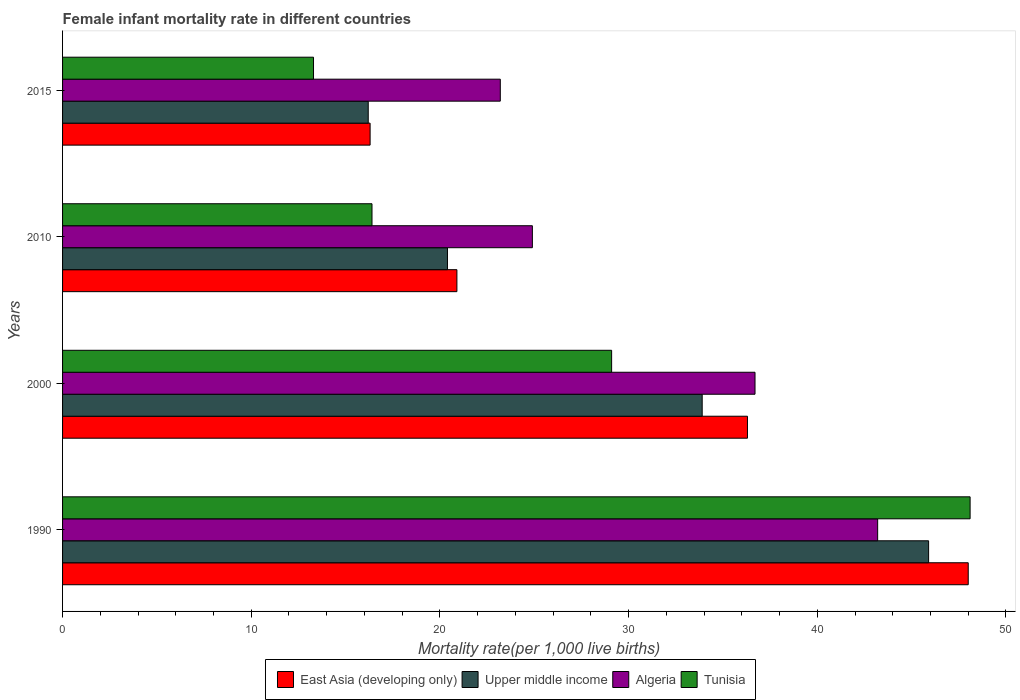Are the number of bars per tick equal to the number of legend labels?
Provide a succinct answer. Yes. Are the number of bars on each tick of the Y-axis equal?
Provide a succinct answer. Yes. How many bars are there on the 2nd tick from the bottom?
Provide a short and direct response. 4. What is the label of the 2nd group of bars from the top?
Your response must be concise. 2010. What is the female infant mortality rate in Algeria in 1990?
Offer a terse response. 43.2. Across all years, what is the maximum female infant mortality rate in East Asia (developing only)?
Your answer should be compact. 48. Across all years, what is the minimum female infant mortality rate in Upper middle income?
Give a very brief answer. 16.2. In which year was the female infant mortality rate in Algeria maximum?
Give a very brief answer. 1990. In which year was the female infant mortality rate in East Asia (developing only) minimum?
Ensure brevity in your answer.  2015. What is the total female infant mortality rate in Algeria in the graph?
Your answer should be very brief. 128. What is the difference between the female infant mortality rate in Tunisia in 1990 and that in 2010?
Keep it short and to the point. 31.7. What is the difference between the female infant mortality rate in East Asia (developing only) in 1990 and the female infant mortality rate in Algeria in 2010?
Provide a short and direct response. 23.1. In the year 2010, what is the difference between the female infant mortality rate in East Asia (developing only) and female infant mortality rate in Tunisia?
Keep it short and to the point. 4.5. What is the ratio of the female infant mortality rate in Upper middle income in 2010 to that in 2015?
Give a very brief answer. 1.26. Is the female infant mortality rate in Algeria in 2010 less than that in 2015?
Ensure brevity in your answer.  No. Is the difference between the female infant mortality rate in East Asia (developing only) in 1990 and 2000 greater than the difference between the female infant mortality rate in Tunisia in 1990 and 2000?
Your response must be concise. No. What is the difference between the highest and the second highest female infant mortality rate in East Asia (developing only)?
Your answer should be very brief. 11.7. What is the difference between the highest and the lowest female infant mortality rate in East Asia (developing only)?
Offer a very short reply. 31.7. In how many years, is the female infant mortality rate in Tunisia greater than the average female infant mortality rate in Tunisia taken over all years?
Provide a short and direct response. 2. Is it the case that in every year, the sum of the female infant mortality rate in Upper middle income and female infant mortality rate in Algeria is greater than the sum of female infant mortality rate in Tunisia and female infant mortality rate in East Asia (developing only)?
Your answer should be compact. No. What does the 3rd bar from the top in 1990 represents?
Provide a succinct answer. Upper middle income. What does the 4th bar from the bottom in 2000 represents?
Your answer should be very brief. Tunisia. Are all the bars in the graph horizontal?
Offer a terse response. Yes. How many years are there in the graph?
Your response must be concise. 4. Are the values on the major ticks of X-axis written in scientific E-notation?
Your response must be concise. No. Does the graph contain any zero values?
Provide a short and direct response. No. Does the graph contain grids?
Offer a terse response. No. What is the title of the graph?
Your answer should be very brief. Female infant mortality rate in different countries. What is the label or title of the X-axis?
Give a very brief answer. Mortality rate(per 1,0 live births). What is the Mortality rate(per 1,000 live births) in East Asia (developing only) in 1990?
Your response must be concise. 48. What is the Mortality rate(per 1,000 live births) in Upper middle income in 1990?
Provide a short and direct response. 45.9. What is the Mortality rate(per 1,000 live births) of Algeria in 1990?
Your answer should be very brief. 43.2. What is the Mortality rate(per 1,000 live births) of Tunisia in 1990?
Your response must be concise. 48.1. What is the Mortality rate(per 1,000 live births) in East Asia (developing only) in 2000?
Your answer should be compact. 36.3. What is the Mortality rate(per 1,000 live births) in Upper middle income in 2000?
Offer a very short reply. 33.9. What is the Mortality rate(per 1,000 live births) in Algeria in 2000?
Ensure brevity in your answer.  36.7. What is the Mortality rate(per 1,000 live births) of Tunisia in 2000?
Offer a very short reply. 29.1. What is the Mortality rate(per 1,000 live births) of East Asia (developing only) in 2010?
Keep it short and to the point. 20.9. What is the Mortality rate(per 1,000 live births) of Upper middle income in 2010?
Make the answer very short. 20.4. What is the Mortality rate(per 1,000 live births) of Algeria in 2010?
Offer a very short reply. 24.9. What is the Mortality rate(per 1,000 live births) in Tunisia in 2010?
Provide a succinct answer. 16.4. What is the Mortality rate(per 1,000 live births) in Upper middle income in 2015?
Provide a short and direct response. 16.2. What is the Mortality rate(per 1,000 live births) of Algeria in 2015?
Give a very brief answer. 23.2. What is the Mortality rate(per 1,000 live births) of Tunisia in 2015?
Make the answer very short. 13.3. Across all years, what is the maximum Mortality rate(per 1,000 live births) of East Asia (developing only)?
Make the answer very short. 48. Across all years, what is the maximum Mortality rate(per 1,000 live births) in Upper middle income?
Your response must be concise. 45.9. Across all years, what is the maximum Mortality rate(per 1,000 live births) in Algeria?
Give a very brief answer. 43.2. Across all years, what is the maximum Mortality rate(per 1,000 live births) of Tunisia?
Ensure brevity in your answer.  48.1. Across all years, what is the minimum Mortality rate(per 1,000 live births) of East Asia (developing only)?
Your answer should be very brief. 16.3. Across all years, what is the minimum Mortality rate(per 1,000 live births) of Algeria?
Offer a very short reply. 23.2. Across all years, what is the minimum Mortality rate(per 1,000 live births) in Tunisia?
Your answer should be very brief. 13.3. What is the total Mortality rate(per 1,000 live births) in East Asia (developing only) in the graph?
Your answer should be compact. 121.5. What is the total Mortality rate(per 1,000 live births) of Upper middle income in the graph?
Give a very brief answer. 116.4. What is the total Mortality rate(per 1,000 live births) in Algeria in the graph?
Your answer should be very brief. 128. What is the total Mortality rate(per 1,000 live births) in Tunisia in the graph?
Your response must be concise. 106.9. What is the difference between the Mortality rate(per 1,000 live births) in East Asia (developing only) in 1990 and that in 2000?
Provide a succinct answer. 11.7. What is the difference between the Mortality rate(per 1,000 live births) in Algeria in 1990 and that in 2000?
Your answer should be compact. 6.5. What is the difference between the Mortality rate(per 1,000 live births) of East Asia (developing only) in 1990 and that in 2010?
Your answer should be very brief. 27.1. What is the difference between the Mortality rate(per 1,000 live births) of Upper middle income in 1990 and that in 2010?
Offer a very short reply. 25.5. What is the difference between the Mortality rate(per 1,000 live births) in Algeria in 1990 and that in 2010?
Make the answer very short. 18.3. What is the difference between the Mortality rate(per 1,000 live births) of Tunisia in 1990 and that in 2010?
Ensure brevity in your answer.  31.7. What is the difference between the Mortality rate(per 1,000 live births) of East Asia (developing only) in 1990 and that in 2015?
Give a very brief answer. 31.7. What is the difference between the Mortality rate(per 1,000 live births) of Upper middle income in 1990 and that in 2015?
Keep it short and to the point. 29.7. What is the difference between the Mortality rate(per 1,000 live births) of Algeria in 1990 and that in 2015?
Offer a very short reply. 20. What is the difference between the Mortality rate(per 1,000 live births) in Tunisia in 1990 and that in 2015?
Ensure brevity in your answer.  34.8. What is the difference between the Mortality rate(per 1,000 live births) of East Asia (developing only) in 2000 and that in 2015?
Provide a short and direct response. 20. What is the difference between the Mortality rate(per 1,000 live births) in Upper middle income in 2000 and that in 2015?
Offer a very short reply. 17.7. What is the difference between the Mortality rate(per 1,000 live births) of Algeria in 2000 and that in 2015?
Your response must be concise. 13.5. What is the difference between the Mortality rate(per 1,000 live births) of Upper middle income in 2010 and that in 2015?
Offer a very short reply. 4.2. What is the difference between the Mortality rate(per 1,000 live births) in East Asia (developing only) in 1990 and the Mortality rate(per 1,000 live births) in Upper middle income in 2000?
Offer a terse response. 14.1. What is the difference between the Mortality rate(per 1,000 live births) in East Asia (developing only) in 1990 and the Mortality rate(per 1,000 live births) in Tunisia in 2000?
Keep it short and to the point. 18.9. What is the difference between the Mortality rate(per 1,000 live births) of Upper middle income in 1990 and the Mortality rate(per 1,000 live births) of Tunisia in 2000?
Provide a succinct answer. 16.8. What is the difference between the Mortality rate(per 1,000 live births) of Algeria in 1990 and the Mortality rate(per 1,000 live births) of Tunisia in 2000?
Your response must be concise. 14.1. What is the difference between the Mortality rate(per 1,000 live births) of East Asia (developing only) in 1990 and the Mortality rate(per 1,000 live births) of Upper middle income in 2010?
Give a very brief answer. 27.6. What is the difference between the Mortality rate(per 1,000 live births) in East Asia (developing only) in 1990 and the Mortality rate(per 1,000 live births) in Algeria in 2010?
Provide a succinct answer. 23.1. What is the difference between the Mortality rate(per 1,000 live births) in East Asia (developing only) in 1990 and the Mortality rate(per 1,000 live births) in Tunisia in 2010?
Offer a very short reply. 31.6. What is the difference between the Mortality rate(per 1,000 live births) of Upper middle income in 1990 and the Mortality rate(per 1,000 live births) of Tunisia in 2010?
Give a very brief answer. 29.5. What is the difference between the Mortality rate(per 1,000 live births) of Algeria in 1990 and the Mortality rate(per 1,000 live births) of Tunisia in 2010?
Your answer should be compact. 26.8. What is the difference between the Mortality rate(per 1,000 live births) in East Asia (developing only) in 1990 and the Mortality rate(per 1,000 live births) in Upper middle income in 2015?
Give a very brief answer. 31.8. What is the difference between the Mortality rate(per 1,000 live births) of East Asia (developing only) in 1990 and the Mortality rate(per 1,000 live births) of Algeria in 2015?
Your response must be concise. 24.8. What is the difference between the Mortality rate(per 1,000 live births) in East Asia (developing only) in 1990 and the Mortality rate(per 1,000 live births) in Tunisia in 2015?
Give a very brief answer. 34.7. What is the difference between the Mortality rate(per 1,000 live births) in Upper middle income in 1990 and the Mortality rate(per 1,000 live births) in Algeria in 2015?
Make the answer very short. 22.7. What is the difference between the Mortality rate(per 1,000 live births) of Upper middle income in 1990 and the Mortality rate(per 1,000 live births) of Tunisia in 2015?
Ensure brevity in your answer.  32.6. What is the difference between the Mortality rate(per 1,000 live births) of Algeria in 1990 and the Mortality rate(per 1,000 live births) of Tunisia in 2015?
Ensure brevity in your answer.  29.9. What is the difference between the Mortality rate(per 1,000 live births) of Upper middle income in 2000 and the Mortality rate(per 1,000 live births) of Tunisia in 2010?
Your response must be concise. 17.5. What is the difference between the Mortality rate(per 1,000 live births) in Algeria in 2000 and the Mortality rate(per 1,000 live births) in Tunisia in 2010?
Keep it short and to the point. 20.3. What is the difference between the Mortality rate(per 1,000 live births) in East Asia (developing only) in 2000 and the Mortality rate(per 1,000 live births) in Upper middle income in 2015?
Offer a terse response. 20.1. What is the difference between the Mortality rate(per 1,000 live births) of East Asia (developing only) in 2000 and the Mortality rate(per 1,000 live births) of Algeria in 2015?
Make the answer very short. 13.1. What is the difference between the Mortality rate(per 1,000 live births) of Upper middle income in 2000 and the Mortality rate(per 1,000 live births) of Tunisia in 2015?
Offer a terse response. 20.6. What is the difference between the Mortality rate(per 1,000 live births) of Algeria in 2000 and the Mortality rate(per 1,000 live births) of Tunisia in 2015?
Your answer should be very brief. 23.4. What is the difference between the Mortality rate(per 1,000 live births) in East Asia (developing only) in 2010 and the Mortality rate(per 1,000 live births) in Upper middle income in 2015?
Offer a terse response. 4.7. What is the difference between the Mortality rate(per 1,000 live births) in East Asia (developing only) in 2010 and the Mortality rate(per 1,000 live births) in Tunisia in 2015?
Keep it short and to the point. 7.6. What is the difference between the Mortality rate(per 1,000 live births) of Upper middle income in 2010 and the Mortality rate(per 1,000 live births) of Tunisia in 2015?
Your response must be concise. 7.1. What is the difference between the Mortality rate(per 1,000 live births) in Algeria in 2010 and the Mortality rate(per 1,000 live births) in Tunisia in 2015?
Offer a terse response. 11.6. What is the average Mortality rate(per 1,000 live births) of East Asia (developing only) per year?
Make the answer very short. 30.38. What is the average Mortality rate(per 1,000 live births) of Upper middle income per year?
Make the answer very short. 29.1. What is the average Mortality rate(per 1,000 live births) in Tunisia per year?
Make the answer very short. 26.73. In the year 1990, what is the difference between the Mortality rate(per 1,000 live births) of East Asia (developing only) and Mortality rate(per 1,000 live births) of Upper middle income?
Your answer should be very brief. 2.1. In the year 1990, what is the difference between the Mortality rate(per 1,000 live births) of East Asia (developing only) and Mortality rate(per 1,000 live births) of Tunisia?
Offer a terse response. -0.1. In the year 2000, what is the difference between the Mortality rate(per 1,000 live births) in East Asia (developing only) and Mortality rate(per 1,000 live births) in Upper middle income?
Offer a terse response. 2.4. In the year 2000, what is the difference between the Mortality rate(per 1,000 live births) of East Asia (developing only) and Mortality rate(per 1,000 live births) of Algeria?
Your answer should be very brief. -0.4. In the year 2000, what is the difference between the Mortality rate(per 1,000 live births) in Upper middle income and Mortality rate(per 1,000 live births) in Algeria?
Your response must be concise. -2.8. In the year 2000, what is the difference between the Mortality rate(per 1,000 live births) of Upper middle income and Mortality rate(per 1,000 live births) of Tunisia?
Your answer should be compact. 4.8. In the year 2010, what is the difference between the Mortality rate(per 1,000 live births) in East Asia (developing only) and Mortality rate(per 1,000 live births) in Upper middle income?
Make the answer very short. 0.5. In the year 2010, what is the difference between the Mortality rate(per 1,000 live births) in East Asia (developing only) and Mortality rate(per 1,000 live births) in Algeria?
Offer a very short reply. -4. In the year 2010, what is the difference between the Mortality rate(per 1,000 live births) of Upper middle income and Mortality rate(per 1,000 live births) of Algeria?
Give a very brief answer. -4.5. In the year 2010, what is the difference between the Mortality rate(per 1,000 live births) in Upper middle income and Mortality rate(per 1,000 live births) in Tunisia?
Provide a short and direct response. 4. In the year 2015, what is the difference between the Mortality rate(per 1,000 live births) of East Asia (developing only) and Mortality rate(per 1,000 live births) of Tunisia?
Your answer should be very brief. 3. What is the ratio of the Mortality rate(per 1,000 live births) in East Asia (developing only) in 1990 to that in 2000?
Keep it short and to the point. 1.32. What is the ratio of the Mortality rate(per 1,000 live births) in Upper middle income in 1990 to that in 2000?
Your answer should be very brief. 1.35. What is the ratio of the Mortality rate(per 1,000 live births) of Algeria in 1990 to that in 2000?
Ensure brevity in your answer.  1.18. What is the ratio of the Mortality rate(per 1,000 live births) of Tunisia in 1990 to that in 2000?
Give a very brief answer. 1.65. What is the ratio of the Mortality rate(per 1,000 live births) in East Asia (developing only) in 1990 to that in 2010?
Offer a terse response. 2.3. What is the ratio of the Mortality rate(per 1,000 live births) of Upper middle income in 1990 to that in 2010?
Provide a short and direct response. 2.25. What is the ratio of the Mortality rate(per 1,000 live births) in Algeria in 1990 to that in 2010?
Offer a very short reply. 1.73. What is the ratio of the Mortality rate(per 1,000 live births) of Tunisia in 1990 to that in 2010?
Your answer should be very brief. 2.93. What is the ratio of the Mortality rate(per 1,000 live births) in East Asia (developing only) in 1990 to that in 2015?
Offer a terse response. 2.94. What is the ratio of the Mortality rate(per 1,000 live births) in Upper middle income in 1990 to that in 2015?
Your answer should be very brief. 2.83. What is the ratio of the Mortality rate(per 1,000 live births) in Algeria in 1990 to that in 2015?
Provide a short and direct response. 1.86. What is the ratio of the Mortality rate(per 1,000 live births) in Tunisia in 1990 to that in 2015?
Your answer should be very brief. 3.62. What is the ratio of the Mortality rate(per 1,000 live births) of East Asia (developing only) in 2000 to that in 2010?
Give a very brief answer. 1.74. What is the ratio of the Mortality rate(per 1,000 live births) of Upper middle income in 2000 to that in 2010?
Provide a short and direct response. 1.66. What is the ratio of the Mortality rate(per 1,000 live births) of Algeria in 2000 to that in 2010?
Give a very brief answer. 1.47. What is the ratio of the Mortality rate(per 1,000 live births) in Tunisia in 2000 to that in 2010?
Provide a short and direct response. 1.77. What is the ratio of the Mortality rate(per 1,000 live births) in East Asia (developing only) in 2000 to that in 2015?
Ensure brevity in your answer.  2.23. What is the ratio of the Mortality rate(per 1,000 live births) of Upper middle income in 2000 to that in 2015?
Your answer should be very brief. 2.09. What is the ratio of the Mortality rate(per 1,000 live births) in Algeria in 2000 to that in 2015?
Keep it short and to the point. 1.58. What is the ratio of the Mortality rate(per 1,000 live births) in Tunisia in 2000 to that in 2015?
Your response must be concise. 2.19. What is the ratio of the Mortality rate(per 1,000 live births) in East Asia (developing only) in 2010 to that in 2015?
Provide a succinct answer. 1.28. What is the ratio of the Mortality rate(per 1,000 live births) of Upper middle income in 2010 to that in 2015?
Keep it short and to the point. 1.26. What is the ratio of the Mortality rate(per 1,000 live births) of Algeria in 2010 to that in 2015?
Provide a short and direct response. 1.07. What is the ratio of the Mortality rate(per 1,000 live births) of Tunisia in 2010 to that in 2015?
Make the answer very short. 1.23. What is the difference between the highest and the second highest Mortality rate(per 1,000 live births) in Upper middle income?
Your response must be concise. 12. What is the difference between the highest and the lowest Mortality rate(per 1,000 live births) in East Asia (developing only)?
Provide a succinct answer. 31.7. What is the difference between the highest and the lowest Mortality rate(per 1,000 live births) in Upper middle income?
Ensure brevity in your answer.  29.7. What is the difference between the highest and the lowest Mortality rate(per 1,000 live births) in Algeria?
Give a very brief answer. 20. What is the difference between the highest and the lowest Mortality rate(per 1,000 live births) in Tunisia?
Ensure brevity in your answer.  34.8. 